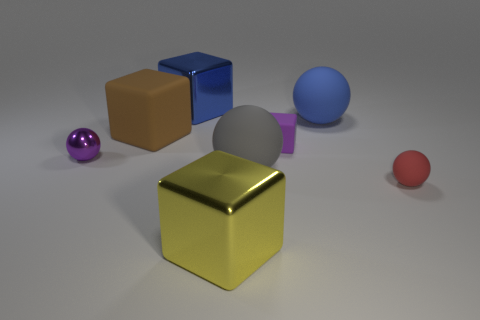What number of other blocks are the same material as the purple cube?
Your answer should be compact. 1. Is the material of the big thing that is in front of the red object the same as the brown object?
Your answer should be very brief. No. Are there more large blue blocks that are on the right side of the tiny block than big metal objects that are in front of the tiny metal ball?
Offer a very short reply. No. There is a purple cube that is the same size as the red matte thing; what is its material?
Provide a short and direct response. Rubber. What number of other objects are the same material as the large blue sphere?
Your response must be concise. 4. Is the shape of the small rubber object that is behind the gray rubber object the same as the large blue object on the left side of the big blue ball?
Provide a short and direct response. Yes. How many other things are the same color as the small metal object?
Offer a very short reply. 1. Does the tiny red thing that is on the right side of the gray rubber thing have the same material as the small thing behind the metal ball?
Your answer should be very brief. Yes. Are there an equal number of gray spheres that are on the left side of the tiny purple metal thing and tiny red things that are behind the small matte sphere?
Your answer should be compact. Yes. What is the ball in front of the gray rubber object made of?
Give a very brief answer. Rubber. 